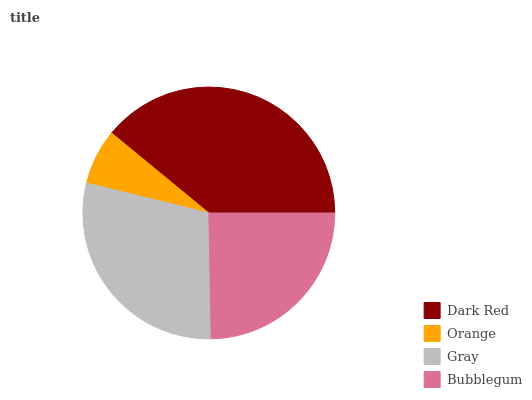Is Orange the minimum?
Answer yes or no. Yes. Is Dark Red the maximum?
Answer yes or no. Yes. Is Gray the minimum?
Answer yes or no. No. Is Gray the maximum?
Answer yes or no. No. Is Gray greater than Orange?
Answer yes or no. Yes. Is Orange less than Gray?
Answer yes or no. Yes. Is Orange greater than Gray?
Answer yes or no. No. Is Gray less than Orange?
Answer yes or no. No. Is Gray the high median?
Answer yes or no. Yes. Is Bubblegum the low median?
Answer yes or no. Yes. Is Orange the high median?
Answer yes or no. No. Is Orange the low median?
Answer yes or no. No. 